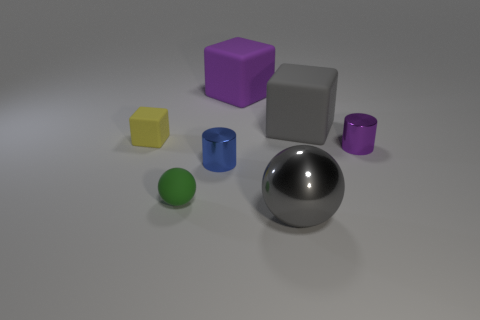Subtract all tiny cubes. How many cubes are left? 2 Add 3 large matte blocks. How many objects exist? 10 Subtract 1 spheres. How many spheres are left? 1 Subtract all gray blocks. How many blocks are left? 2 Add 6 big metallic things. How many big metallic things are left? 7 Add 3 tiny purple objects. How many tiny purple objects exist? 4 Subtract 0 blue balls. How many objects are left? 7 Subtract all cubes. How many objects are left? 4 Subtract all cyan spheres. Subtract all cyan cylinders. How many spheres are left? 2 Subtract all gray cylinders. How many yellow balls are left? 0 